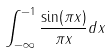<formula> <loc_0><loc_0><loc_500><loc_500>\int _ { - \infty } ^ { - 1 } \frac { \sin ( \pi x ) } { \pi x } d x</formula> 